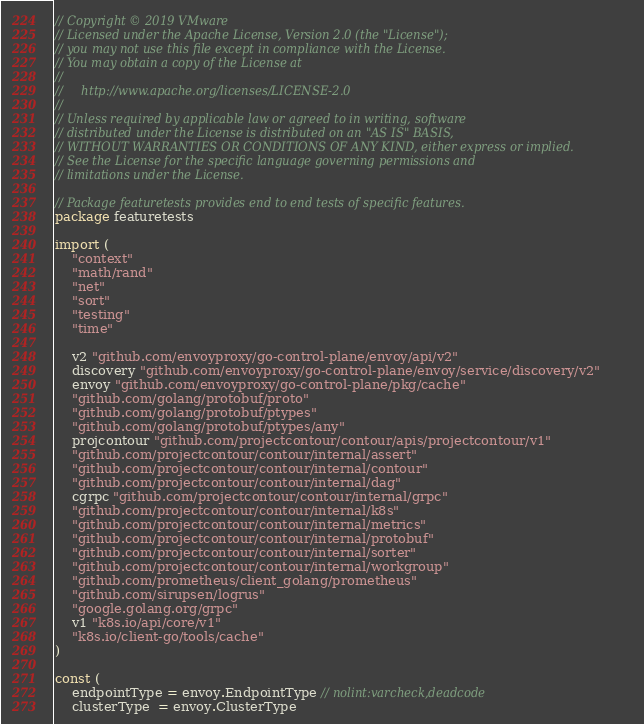<code> <loc_0><loc_0><loc_500><loc_500><_Go_>// Copyright © 2019 VMware
// Licensed under the Apache License, Version 2.0 (the "License");
// you may not use this file except in compliance with the License.
// You may obtain a copy of the License at
//
//     http://www.apache.org/licenses/LICENSE-2.0
//
// Unless required by applicable law or agreed to in writing, software
// distributed under the License is distributed on an "AS IS" BASIS,
// WITHOUT WARRANTIES OR CONDITIONS OF ANY KIND, either express or implied.
// See the License for the specific language governing permissions and
// limitations under the License.

// Package featuretests provides end to end tests of specific features.
package featuretests

import (
	"context"
	"math/rand"
	"net"
	"sort"
	"testing"
	"time"

	v2 "github.com/envoyproxy/go-control-plane/envoy/api/v2"
	discovery "github.com/envoyproxy/go-control-plane/envoy/service/discovery/v2"
	envoy "github.com/envoyproxy/go-control-plane/pkg/cache"
	"github.com/golang/protobuf/proto"
	"github.com/golang/protobuf/ptypes"
	"github.com/golang/protobuf/ptypes/any"
	projcontour "github.com/projectcontour/contour/apis/projectcontour/v1"
	"github.com/projectcontour/contour/internal/assert"
	"github.com/projectcontour/contour/internal/contour"
	"github.com/projectcontour/contour/internal/dag"
	cgrpc "github.com/projectcontour/contour/internal/grpc"
	"github.com/projectcontour/contour/internal/k8s"
	"github.com/projectcontour/contour/internal/metrics"
	"github.com/projectcontour/contour/internal/protobuf"
	"github.com/projectcontour/contour/internal/sorter"
	"github.com/projectcontour/contour/internal/workgroup"
	"github.com/prometheus/client_golang/prometheus"
	"github.com/sirupsen/logrus"
	"google.golang.org/grpc"
	v1 "k8s.io/api/core/v1"
	"k8s.io/client-go/tools/cache"
)

const (
	endpointType = envoy.EndpointType // nolint:varcheck,deadcode
	clusterType  = envoy.ClusterType</code> 